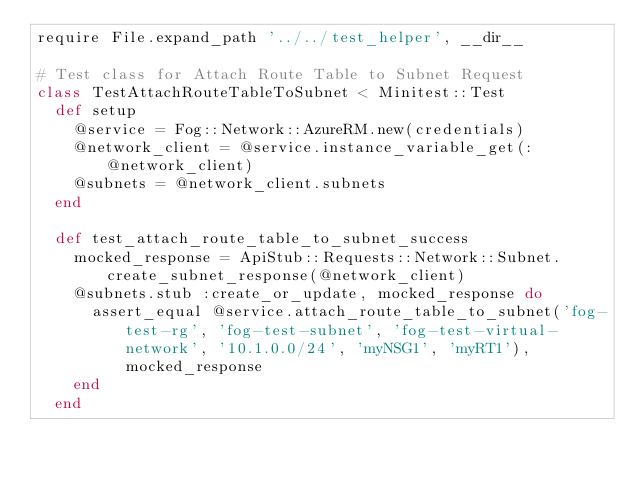Convert code to text. <code><loc_0><loc_0><loc_500><loc_500><_Ruby_>require File.expand_path '../../test_helper', __dir__

# Test class for Attach Route Table to Subnet Request
class TestAttachRouteTableToSubnet < Minitest::Test
  def setup
    @service = Fog::Network::AzureRM.new(credentials)
    @network_client = @service.instance_variable_get(:@network_client)
    @subnets = @network_client.subnets
  end

  def test_attach_route_table_to_subnet_success
    mocked_response = ApiStub::Requests::Network::Subnet.create_subnet_response(@network_client)
    @subnets.stub :create_or_update, mocked_response do
      assert_equal @service.attach_route_table_to_subnet('fog-test-rg', 'fog-test-subnet', 'fog-test-virtual-network', '10.1.0.0/24', 'myNSG1', 'myRT1'), mocked_response
    end
  end
</code> 